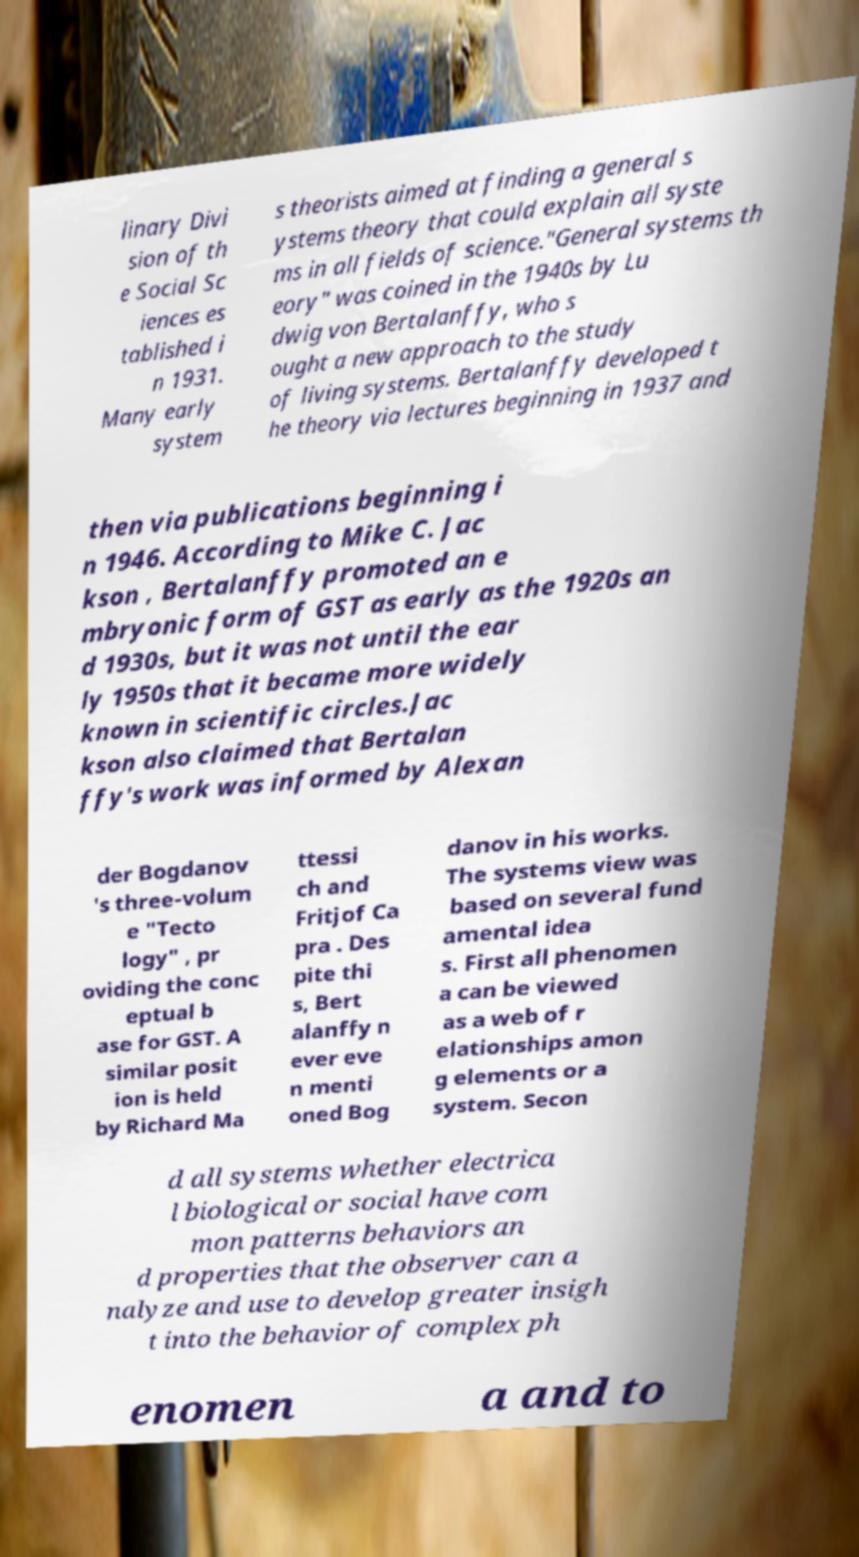Can you read and provide the text displayed in the image?This photo seems to have some interesting text. Can you extract and type it out for me? linary Divi sion of th e Social Sc iences es tablished i n 1931. Many early system s theorists aimed at finding a general s ystems theory that could explain all syste ms in all fields of science."General systems th eory" was coined in the 1940s by Lu dwig von Bertalanffy, who s ought a new approach to the study of living systems. Bertalanffy developed t he theory via lectures beginning in 1937 and then via publications beginning i n 1946. According to Mike C. Jac kson , Bertalanffy promoted an e mbryonic form of GST as early as the 1920s an d 1930s, but it was not until the ear ly 1950s that it became more widely known in scientific circles.Jac kson also claimed that Bertalan ffy's work was informed by Alexan der Bogdanov 's three-volum e "Tecto logy" , pr oviding the conc eptual b ase for GST. A similar posit ion is held by Richard Ma ttessi ch and Fritjof Ca pra . Des pite thi s, Bert alanffy n ever eve n menti oned Bog danov in his works. The systems view was based on several fund amental idea s. First all phenomen a can be viewed as a web of r elationships amon g elements or a system. Secon d all systems whether electrica l biological or social have com mon patterns behaviors an d properties that the observer can a nalyze and use to develop greater insigh t into the behavior of complex ph enomen a and to 